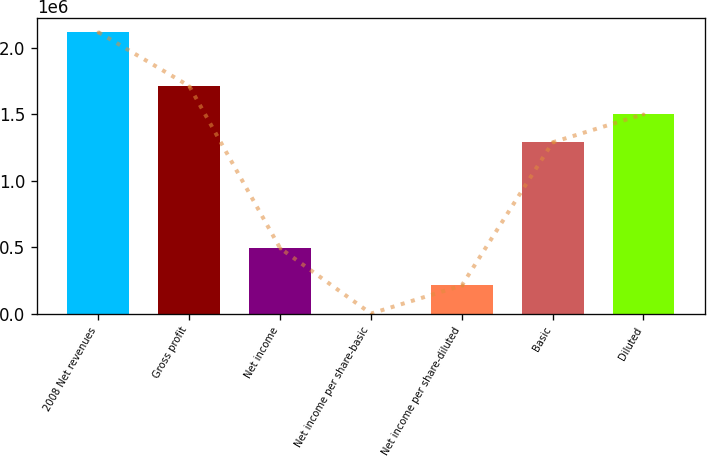<chart> <loc_0><loc_0><loc_500><loc_500><bar_chart><fcel>2008 Net revenues<fcel>Gross profit<fcel>Net income<fcel>Net income per share-basic<fcel>Net income per share-diluted<fcel>Basic<fcel>Diluted<nl><fcel>2.11753e+06<fcel>1.71244e+06<fcel>492219<fcel>0.38<fcel>211753<fcel>1.28894e+06<fcel>1.50069e+06<nl></chart> 